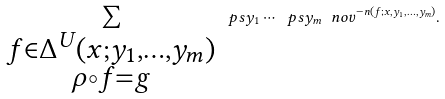Convert formula to latex. <formula><loc_0><loc_0><loc_500><loc_500>\sum _ { \substack { f \in \Delta ^ { U } ( x ; y _ { 1 } , \dots , y _ { m } ) \\ \rho \circ f = g } } \ p s { y } _ { 1 } \cdots \ p s { y } _ { m } \ n o v ^ { - n ( f ; x , y _ { 1 } , \dots , y _ { m } ) } .</formula> 